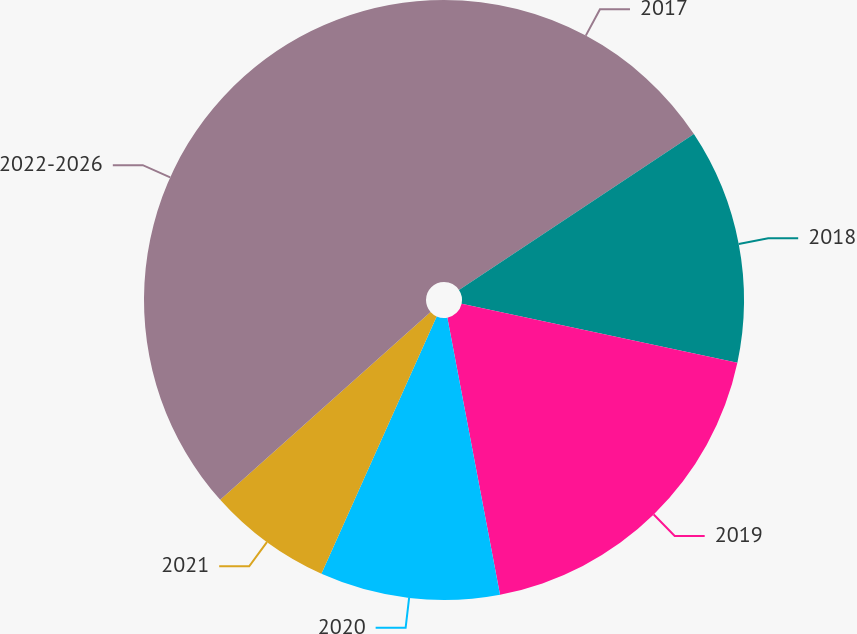Convert chart to OTSL. <chart><loc_0><loc_0><loc_500><loc_500><pie_chart><fcel>2017<fcel>2018<fcel>2019<fcel>2020<fcel>2021<fcel>2022-2026<nl><fcel>15.67%<fcel>12.68%<fcel>18.66%<fcel>9.69%<fcel>6.7%<fcel>36.6%<nl></chart> 